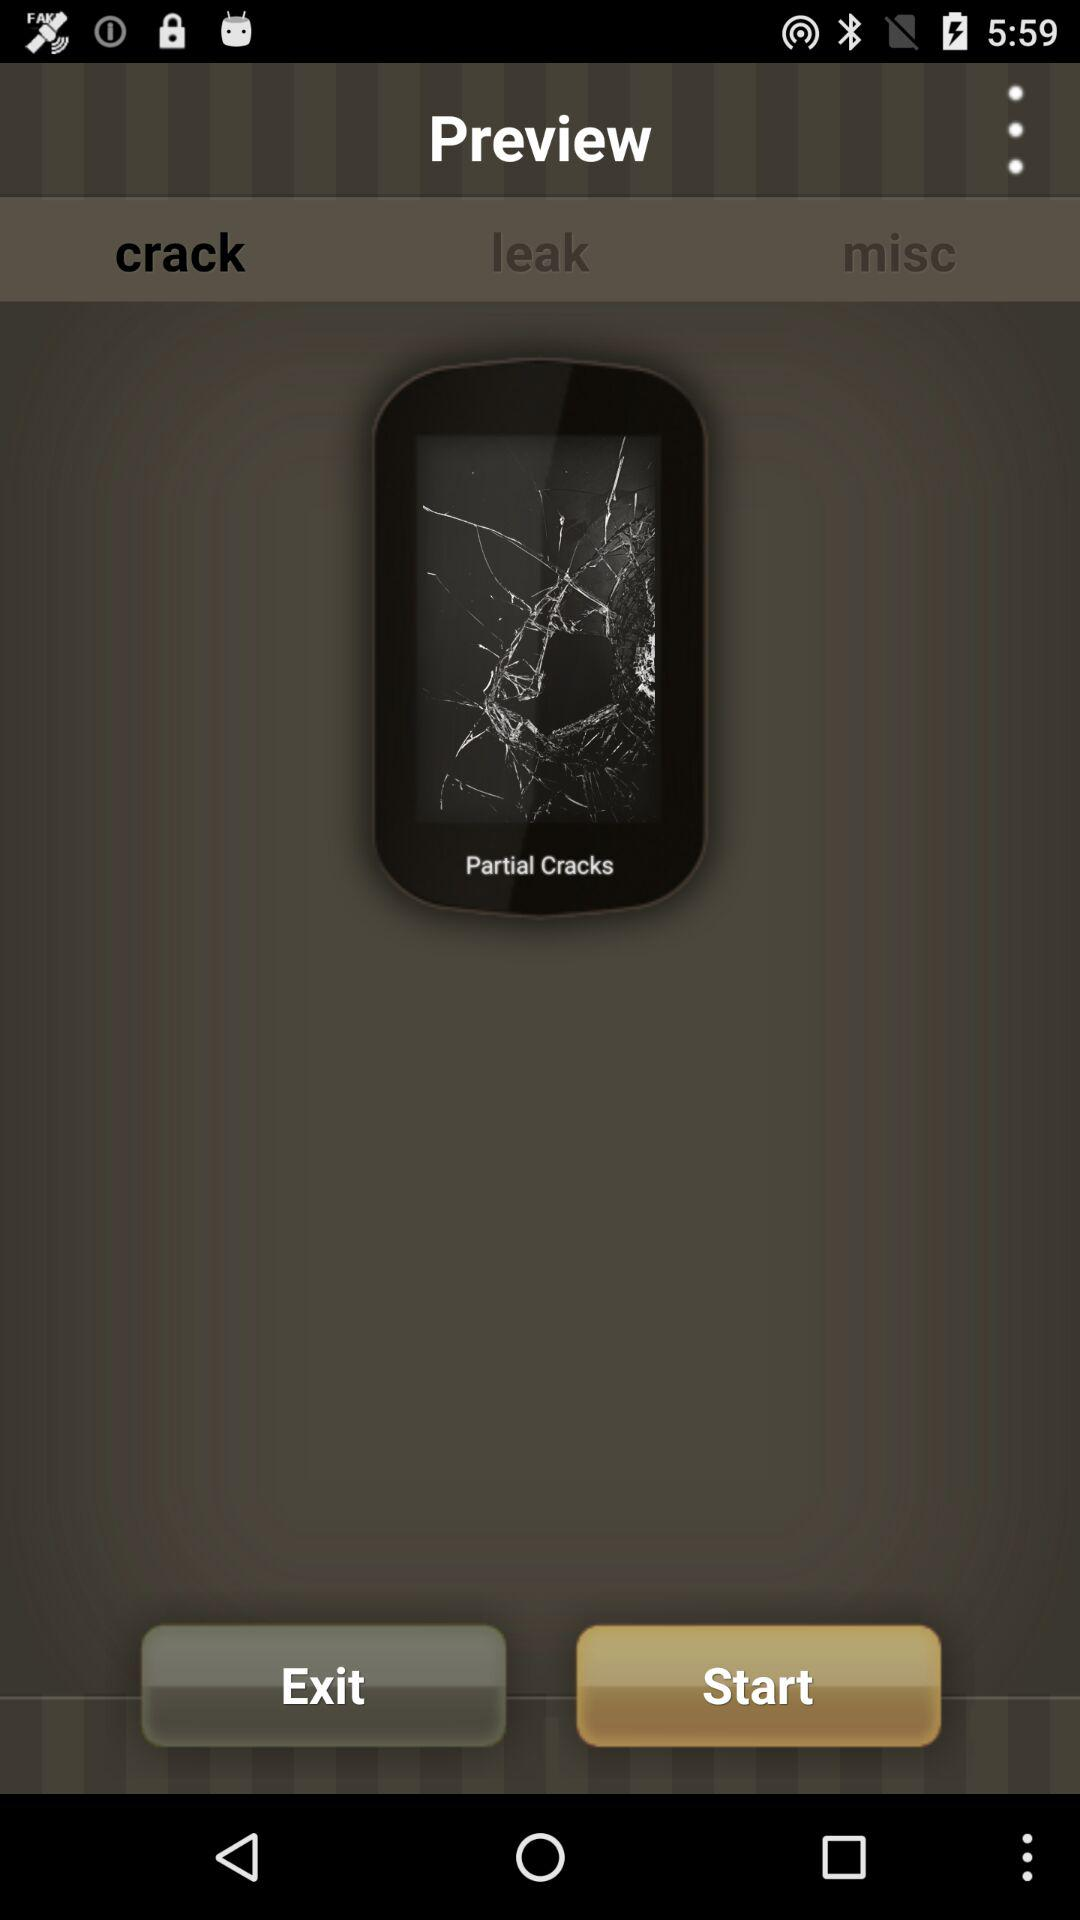Which tab is selected? The selected tab is "crack". 